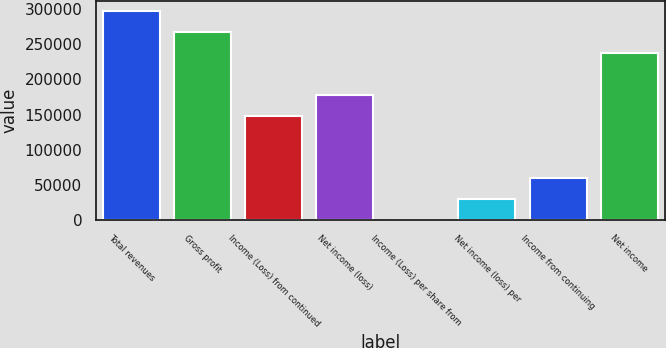Convert chart to OTSL. <chart><loc_0><loc_0><loc_500><loc_500><bar_chart><fcel>Total revenues<fcel>Gross profit<fcel>Income (Loss) from continued<fcel>Net income (loss)<fcel>Income (Loss) per share from<fcel>Net income (loss) per<fcel>Income from continuing<fcel>Net income<nl><fcel>296947<fcel>267252<fcel>148474<fcel>178168<fcel>0.06<fcel>29694.8<fcel>59389.4<fcel>237558<nl></chart> 